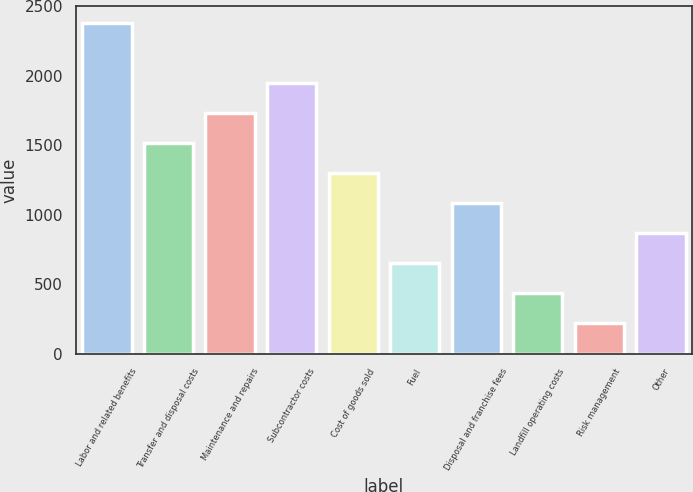Convert chart. <chart><loc_0><loc_0><loc_500><loc_500><bar_chart><fcel>Labor and related benefits<fcel>Transfer and disposal costs<fcel>Maintenance and repairs<fcel>Subcontractor costs<fcel>Cost of goods sold<fcel>Fuel<fcel>Disposal and franchise fees<fcel>Landfill operating costs<fcel>Risk management<fcel>Other<nl><fcel>2381<fcel>1517<fcel>1733<fcel>1949<fcel>1301<fcel>653<fcel>1085<fcel>437<fcel>221<fcel>869<nl></chart> 